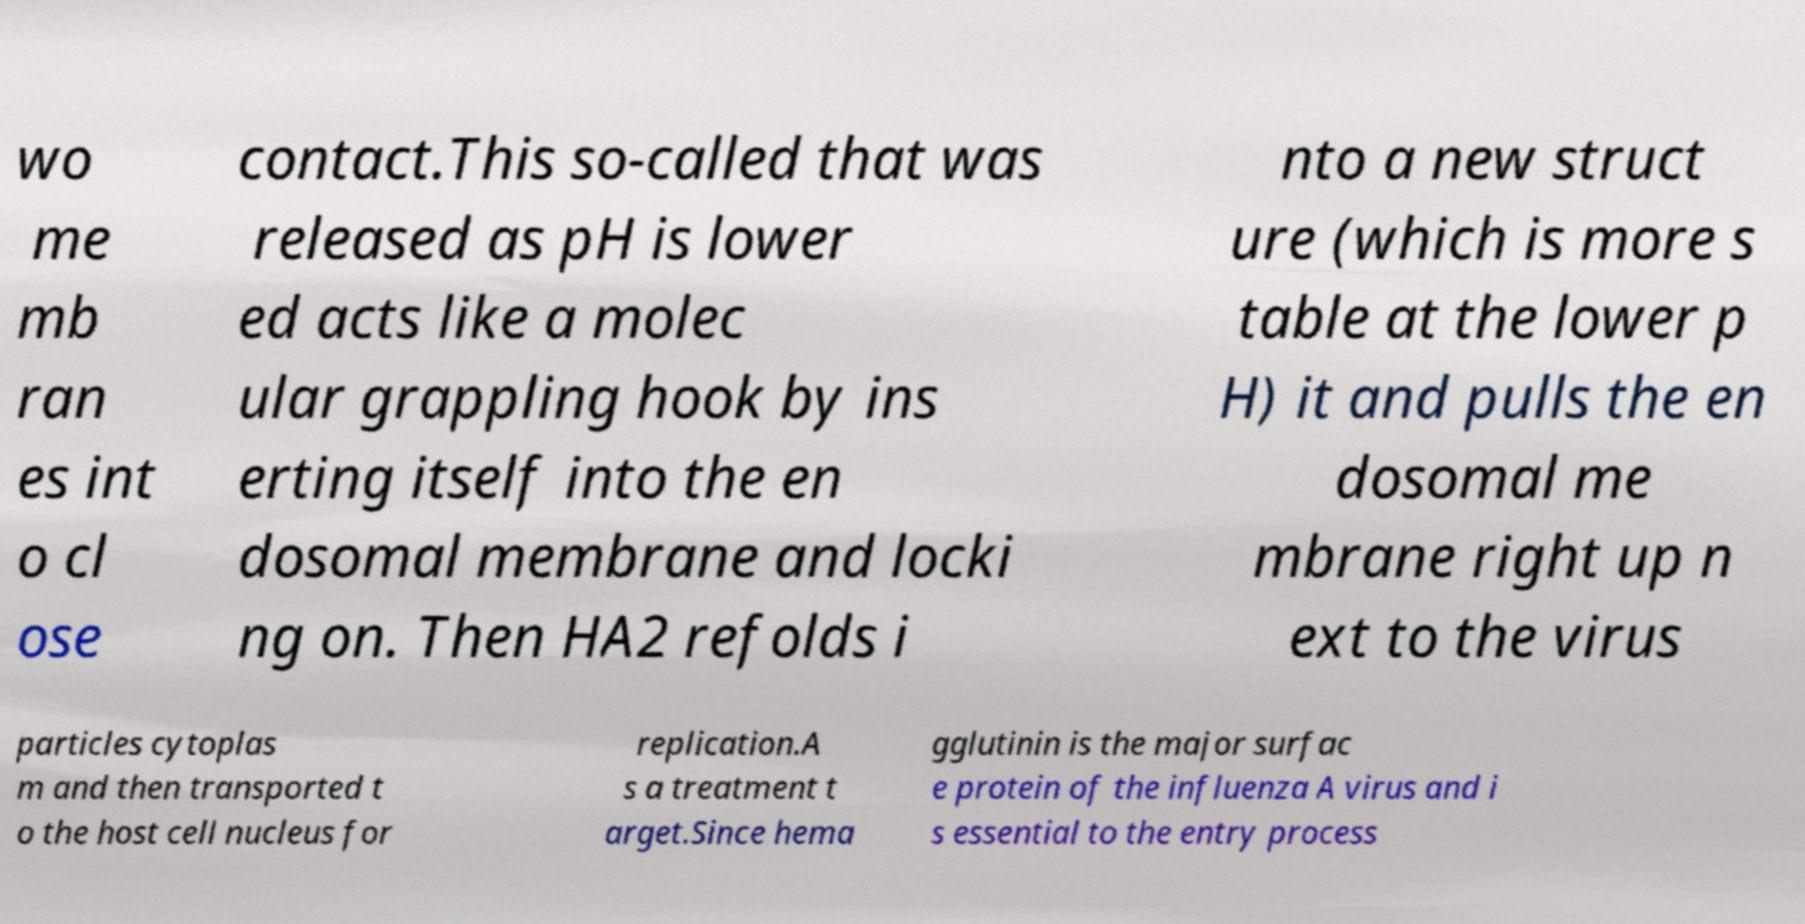What messages or text are displayed in this image? I need them in a readable, typed format. wo me mb ran es int o cl ose contact.This so-called that was released as pH is lower ed acts like a molec ular grappling hook by ins erting itself into the en dosomal membrane and locki ng on. Then HA2 refolds i nto a new struct ure (which is more s table at the lower p H) it and pulls the en dosomal me mbrane right up n ext to the virus particles cytoplas m and then transported t o the host cell nucleus for replication.A s a treatment t arget.Since hema gglutinin is the major surfac e protein of the influenza A virus and i s essential to the entry process 